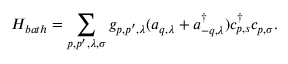Convert formula to latex. <formula><loc_0><loc_0><loc_500><loc_500>H _ { b a t h } = \sum _ { p , p ^ { \prime } , \lambda , \sigma } g _ { p , p ^ { \prime } , \lambda } ( a _ { q , \lambda } + a _ { - q , \lambda } ^ { \dag } ) c _ { p , s } ^ { \dag } c _ { p , \sigma } .</formula> 